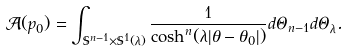<formula> <loc_0><loc_0><loc_500><loc_500>\mathcal { A } ( p _ { 0 } ) = \int _ { \mathbb { S } ^ { n - 1 } \times \mathbb { S } ^ { 1 } ( \lambda ) } \frac { 1 } { \cosh ^ { n } ( \lambda | \theta - \theta _ { 0 } | ) } d \Theta _ { n - 1 } d \Theta _ { \lambda } .</formula> 